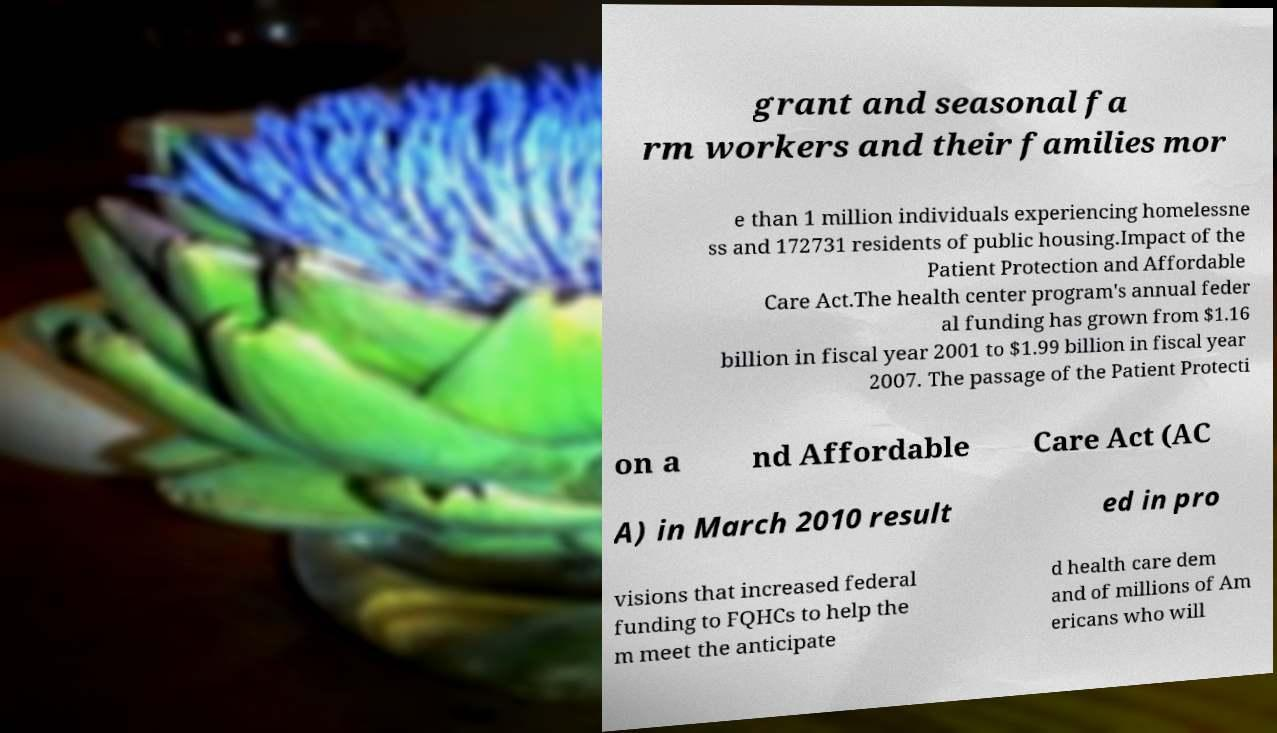Please identify and transcribe the text found in this image. grant and seasonal fa rm workers and their families mor e than 1 million individuals experiencing homelessne ss and 172731 residents of public housing.Impact of the Patient Protection and Affordable Care Act.The health center program's annual feder al funding has grown from $1.16 billion in fiscal year 2001 to $1.99 billion in fiscal year 2007. The passage of the Patient Protecti on a nd Affordable Care Act (AC A) in March 2010 result ed in pro visions that increased federal funding to FQHCs to help the m meet the anticipate d health care dem and of millions of Am ericans who will 